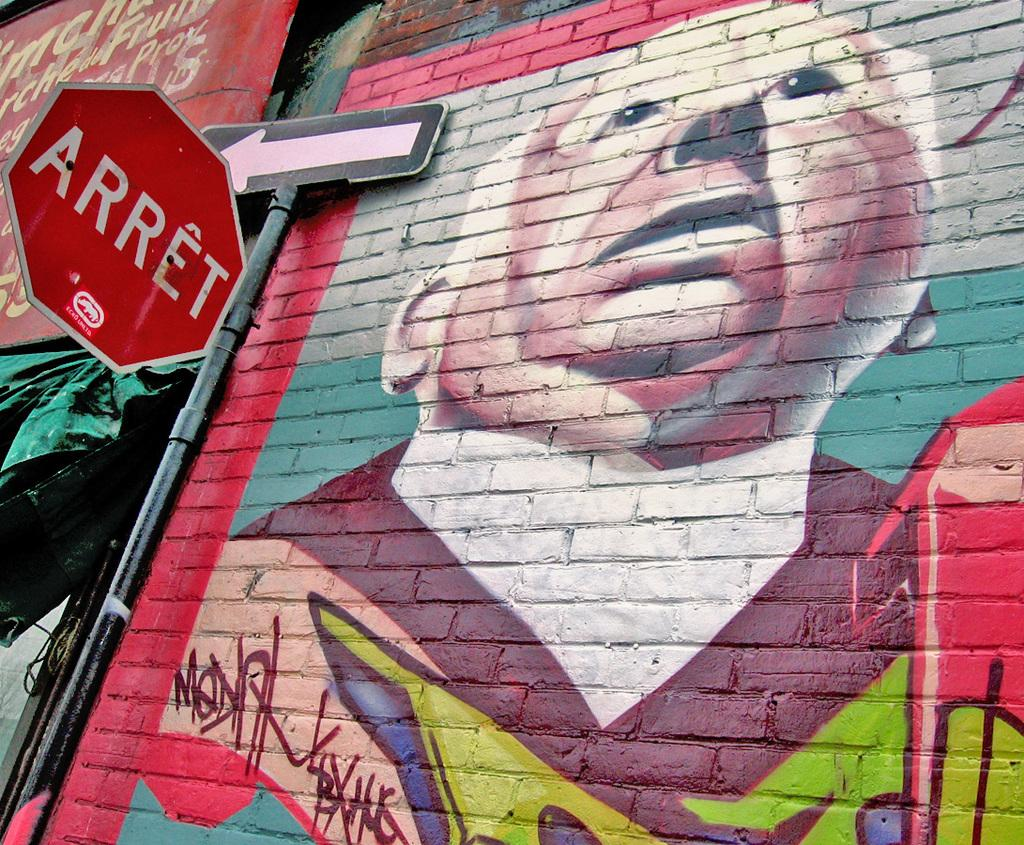<image>
Give a short and clear explanation of the subsequent image. a mural has been painted on a brick wall, beside a sign that is labeled ARRET 